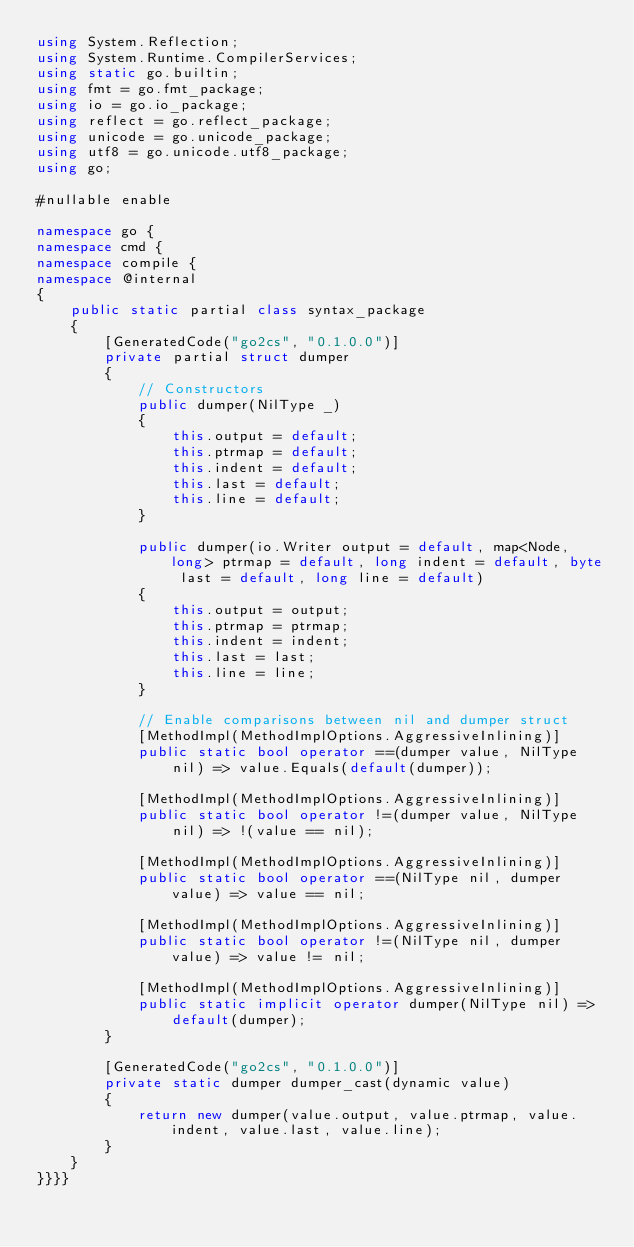<code> <loc_0><loc_0><loc_500><loc_500><_C#_>using System.Reflection;
using System.Runtime.CompilerServices;
using static go.builtin;
using fmt = go.fmt_package;
using io = go.io_package;
using reflect = go.reflect_package;
using unicode = go.unicode_package;
using utf8 = go.unicode.utf8_package;
using go;

#nullable enable

namespace go {
namespace cmd {
namespace compile {
namespace @internal
{
    public static partial class syntax_package
    {
        [GeneratedCode("go2cs", "0.1.0.0")]
        private partial struct dumper
        {
            // Constructors
            public dumper(NilType _)
            {
                this.output = default;
                this.ptrmap = default;
                this.indent = default;
                this.last = default;
                this.line = default;
            }

            public dumper(io.Writer output = default, map<Node, long> ptrmap = default, long indent = default, byte last = default, long line = default)
            {
                this.output = output;
                this.ptrmap = ptrmap;
                this.indent = indent;
                this.last = last;
                this.line = line;
            }

            // Enable comparisons between nil and dumper struct
            [MethodImpl(MethodImplOptions.AggressiveInlining)]
            public static bool operator ==(dumper value, NilType nil) => value.Equals(default(dumper));

            [MethodImpl(MethodImplOptions.AggressiveInlining)]
            public static bool operator !=(dumper value, NilType nil) => !(value == nil);

            [MethodImpl(MethodImplOptions.AggressiveInlining)]
            public static bool operator ==(NilType nil, dumper value) => value == nil;

            [MethodImpl(MethodImplOptions.AggressiveInlining)]
            public static bool operator !=(NilType nil, dumper value) => value != nil;

            [MethodImpl(MethodImplOptions.AggressiveInlining)]
            public static implicit operator dumper(NilType nil) => default(dumper);
        }

        [GeneratedCode("go2cs", "0.1.0.0")]
        private static dumper dumper_cast(dynamic value)
        {
            return new dumper(value.output, value.ptrmap, value.indent, value.last, value.line);
        }
    }
}}}}</code> 